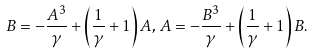Convert formula to latex. <formula><loc_0><loc_0><loc_500><loc_500>B = - \frac { A ^ { 3 } } { \gamma } + \left ( \frac { 1 } { \gamma } + 1 \right ) A , \, A = - \frac { B ^ { 3 } } { \gamma } + \left ( \frac { 1 } { \gamma } + 1 \right ) B .</formula> 